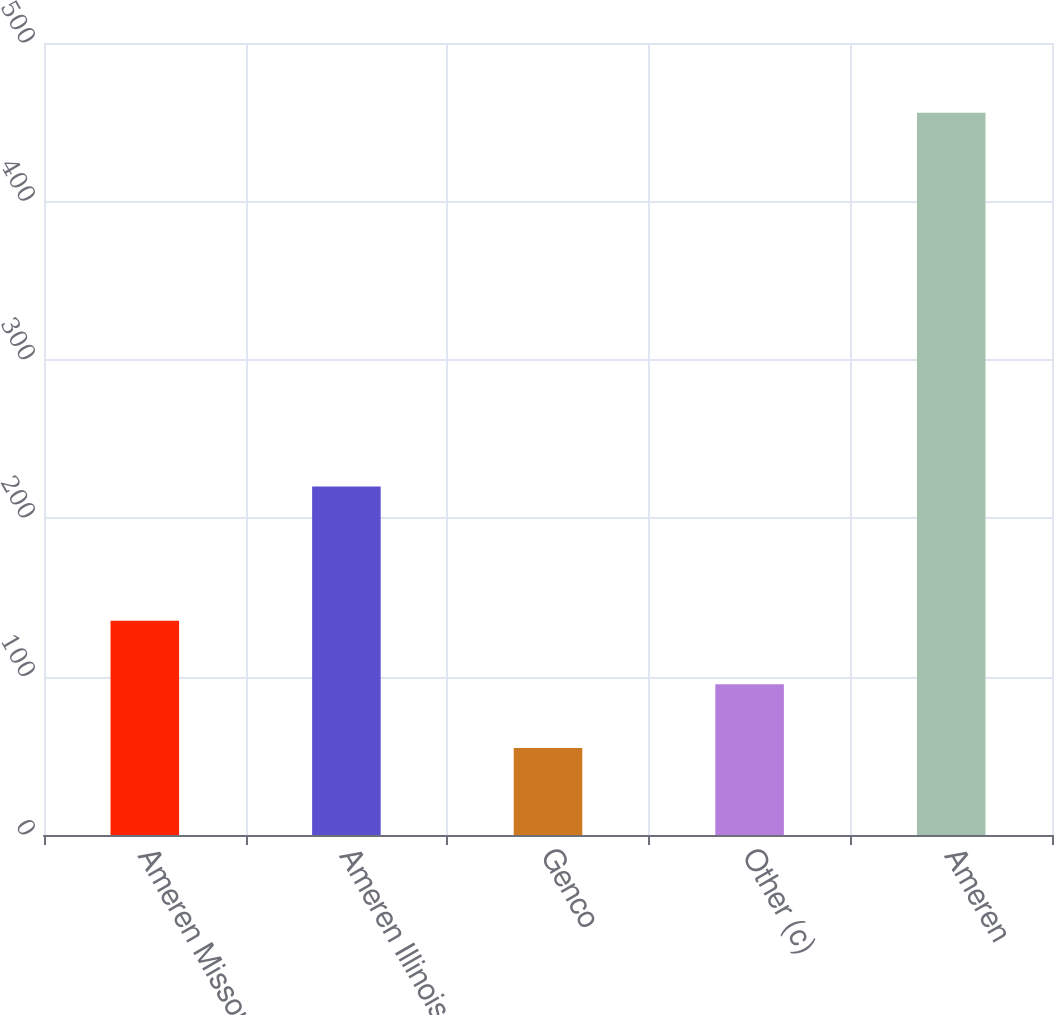<chart> <loc_0><loc_0><loc_500><loc_500><bar_chart><fcel>Ameren Missouri<fcel>Ameren Illinois<fcel>Genco<fcel>Other (c)<fcel>Ameren<nl><fcel>135.2<fcel>220<fcel>55<fcel>95.1<fcel>456<nl></chart> 